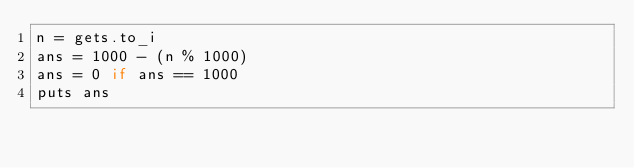<code> <loc_0><loc_0><loc_500><loc_500><_Ruby_>n = gets.to_i
ans = 1000 - (n % 1000)
ans = 0 if ans == 1000
puts ans
</code> 